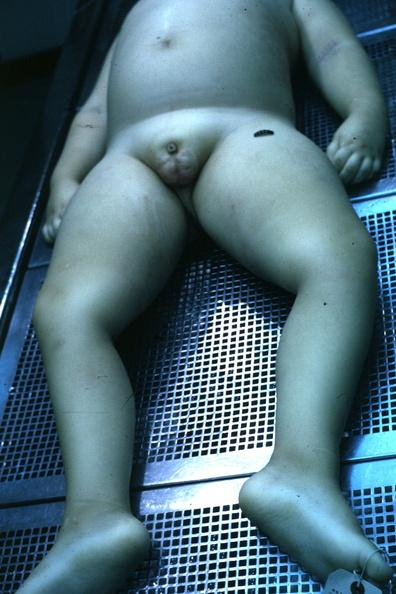does this image show view of body with small penis and rather flat scrotal sac case of 7yo with craniopharyngioma?
Answer the question using a single word or phrase. Yes 